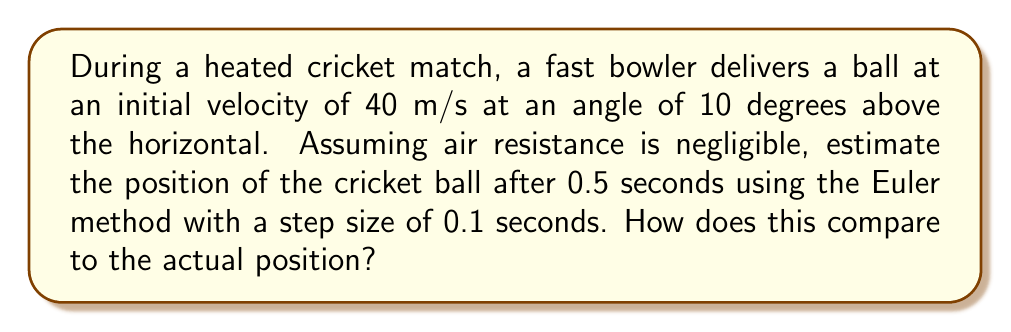Can you answer this question? Let's approach this problem step by step using the Euler method:

1) First, we need to set up our initial conditions:
   Initial position: $x_0 = 0$, $y_0 = 0$
   Initial velocity: $v_x = 40 \cos(10°)$, $v_y = 40 \sin(10°)$

2) Calculate the initial velocities:
   $v_x = 40 \cos(10°) \approx 39.39$ m/s
   $v_y = 40 \sin(10°) \approx 6.95$ m/s

3) The acceleration due to gravity is $g = -9.8$ m/s².

4) Now, we'll use the Euler method to estimate the position. The equations are:
   $$x_{n+1} = x_n + v_x \Delta t$$
   $$y_{n+1} = y_n + v_y \Delta t$$
   $$v_{y,n+1} = v_{y,n} + g \Delta t$$

   Where $\Delta t = 0.1$ s (our step size)

5) Let's calculate for each step:

   Step 1 (t = 0.1 s):
   $x_1 = 0 + 39.39 * 0.1 = 3.939$ m
   $y_1 = 0 + 6.95 * 0.1 = 0.695$ m
   $v_{y,1} = 6.95 + (-9.8) * 0.1 = 5.97$ m/s

   Step 2 (t = 0.2 s):
   $x_2 = 3.939 + 39.39 * 0.1 = 7.878$ m
   $y_2 = 0.695 + 5.97 * 0.1 = 1.292$ m
   $v_{y,2} = 5.97 + (-9.8) * 0.1 = 4.99$ m/s

   Step 3 (t = 0.3 s):
   $x_3 = 7.878 + 39.39 * 0.1 = 11.817$ m
   $y_3 = 1.292 + 4.99 * 0.1 = 1.791$ m
   $v_{y,3} = 4.99 + (-9.8) * 0.1 = 4.01$ m/s

   Step 4 (t = 0.4 s):
   $x_4 = 11.817 + 39.39 * 0.1 = 15.756$ m
   $y_4 = 1.791 + 4.01 * 0.1 = 2.192$ m
   $v_{y,4} = 4.01 + (-9.8) * 0.1 = 3.03$ m/s

   Step 5 (t = 0.5 s):
   $x_5 = 15.756 + 39.39 * 0.1 = 19.695$ m
   $y_5 = 2.192 + 3.03 * 0.1 = 2.495$ m

6) To compare with the actual position, we can use the analytical solution:
   $$x = v_x t = 39.39 * 0.5 = 19.695$$ m
   $$y = v_y t - \frac{1}{2}gt^2 = 6.95 * 0.5 - \frac{1}{2} * 9.8 * 0.5^2 = 2.494$$ m

The Euler method gives us (19.695, 2.495), which is very close to the actual position (19.695, 2.494).
Answer: The estimated position of the cricket ball after 0.5 seconds using the Euler method is (19.695 m, 2.495 m). This is very close to the actual position of (19.695 m, 2.494 m), with only a slight overestimation in the y-coordinate. 